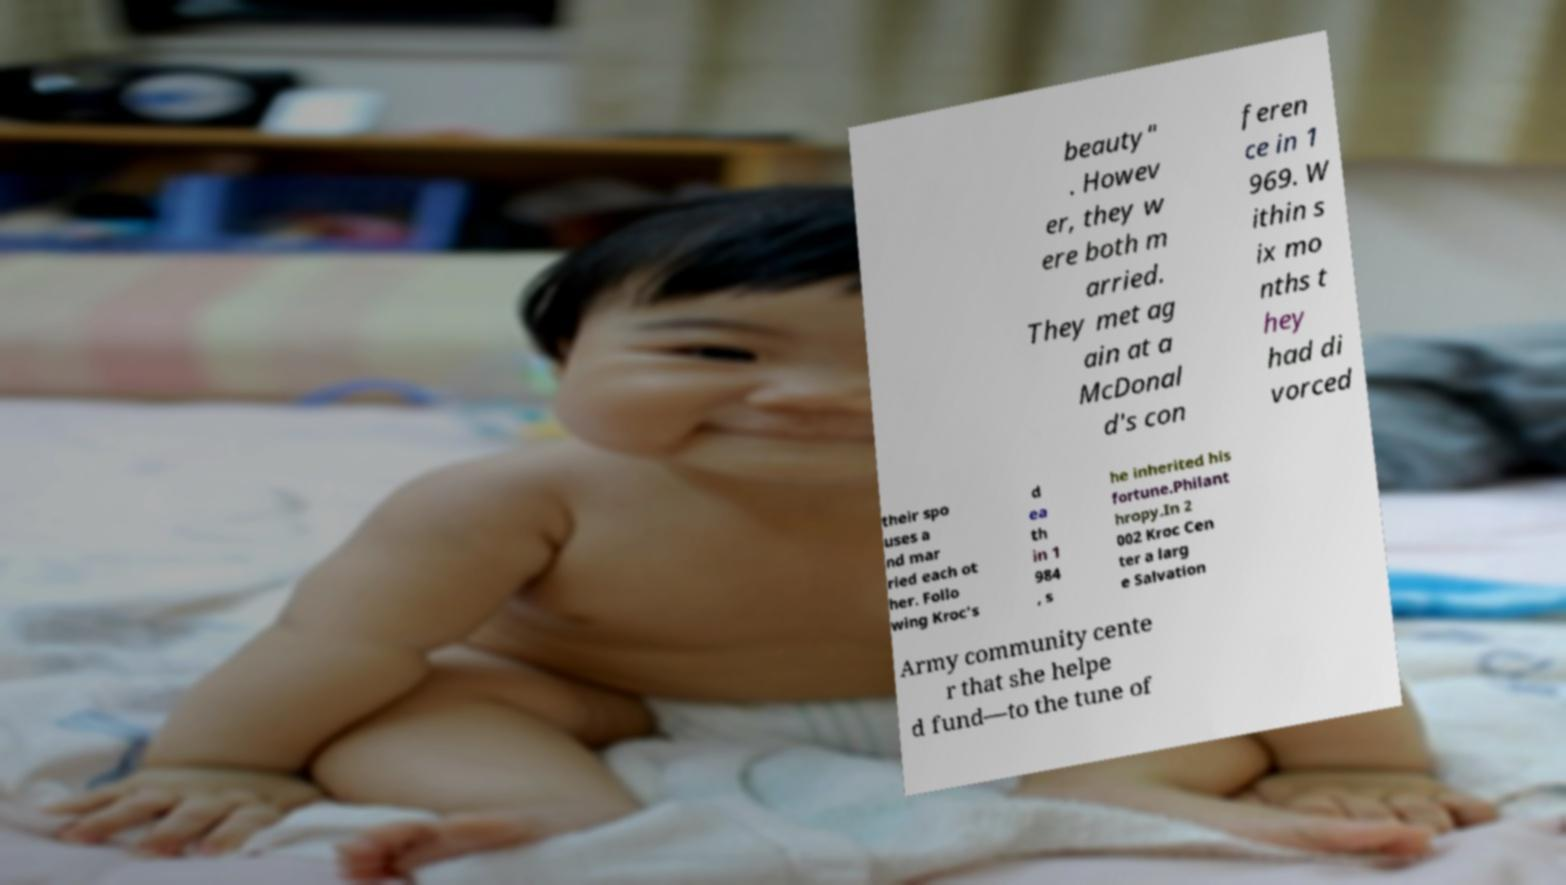Please read and relay the text visible in this image. What does it say? beauty" . Howev er, they w ere both m arried. They met ag ain at a McDonal d's con feren ce in 1 969. W ithin s ix mo nths t hey had di vorced their spo uses a nd mar ried each ot her. Follo wing Kroc's d ea th in 1 984 , s he inherited his fortune.Philant hropy.In 2 002 Kroc Cen ter a larg e Salvation Army community cente r that she helpe d fund—to the tune of 